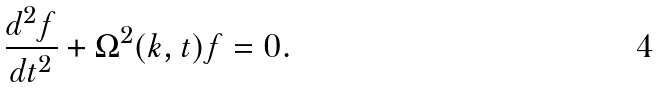<formula> <loc_0><loc_0><loc_500><loc_500>\frac { d ^ { 2 } f } { d t ^ { 2 } } + \Omega ^ { 2 } ( k , t ) f = 0 .</formula> 